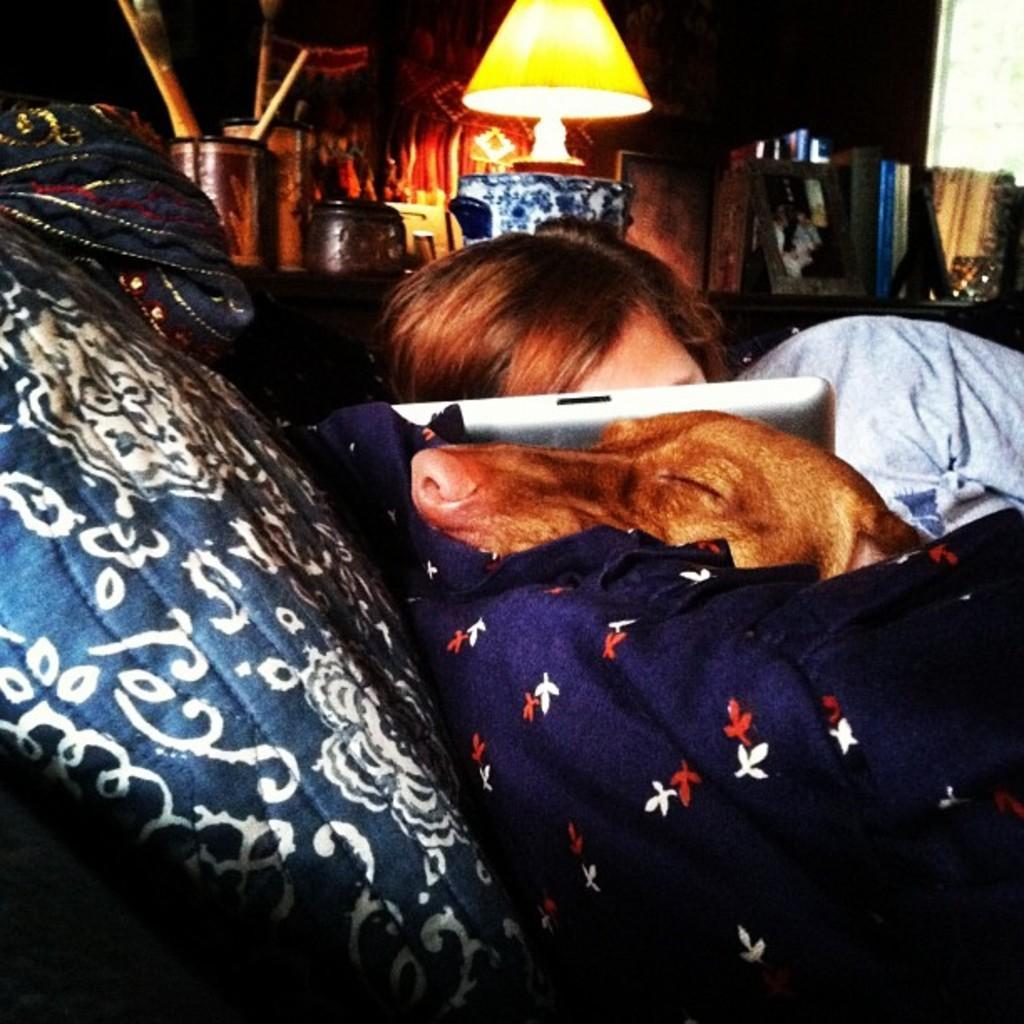How would you summarize this image in a sentence or two? In the center of the image we can see a person and a dog sleeping on the bed. There is a blanket and we can see a tablet. In the background there is a table and we can see a lamp, photo frame, books and jars placed on the table. 